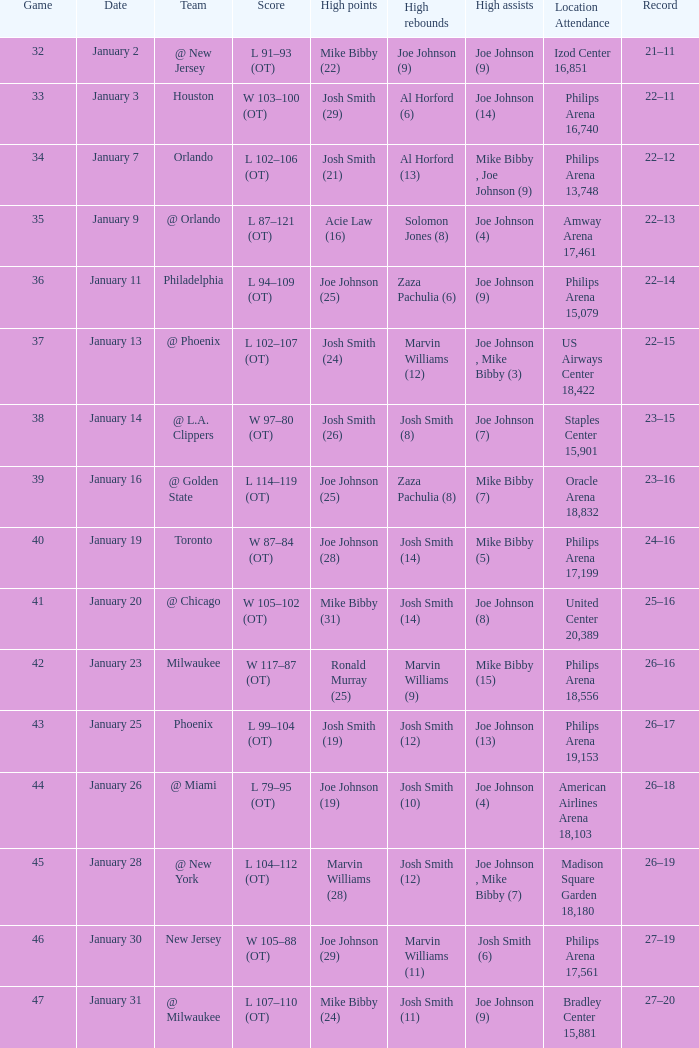On which date did game 35 take place? January 9. 